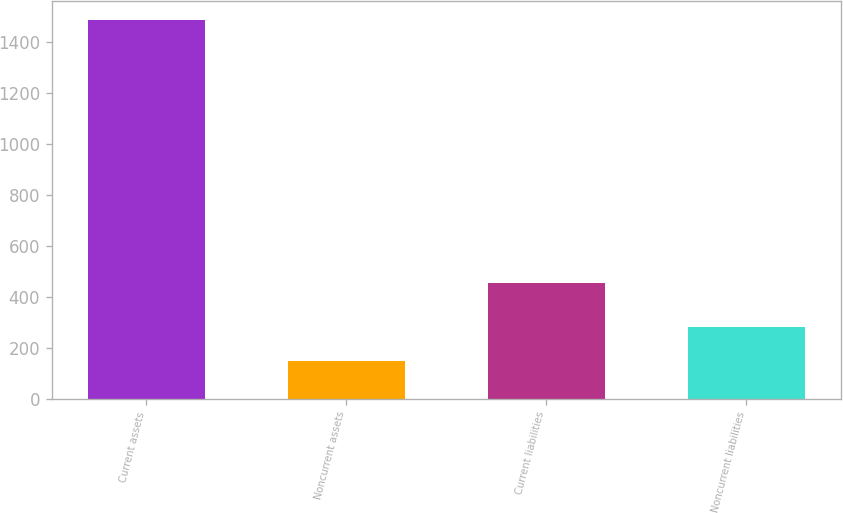<chart> <loc_0><loc_0><loc_500><loc_500><bar_chart><fcel>Current assets<fcel>Noncurrent assets<fcel>Current liabilities<fcel>Noncurrent liabilities<nl><fcel>1486<fcel>149<fcel>456<fcel>282.7<nl></chart> 